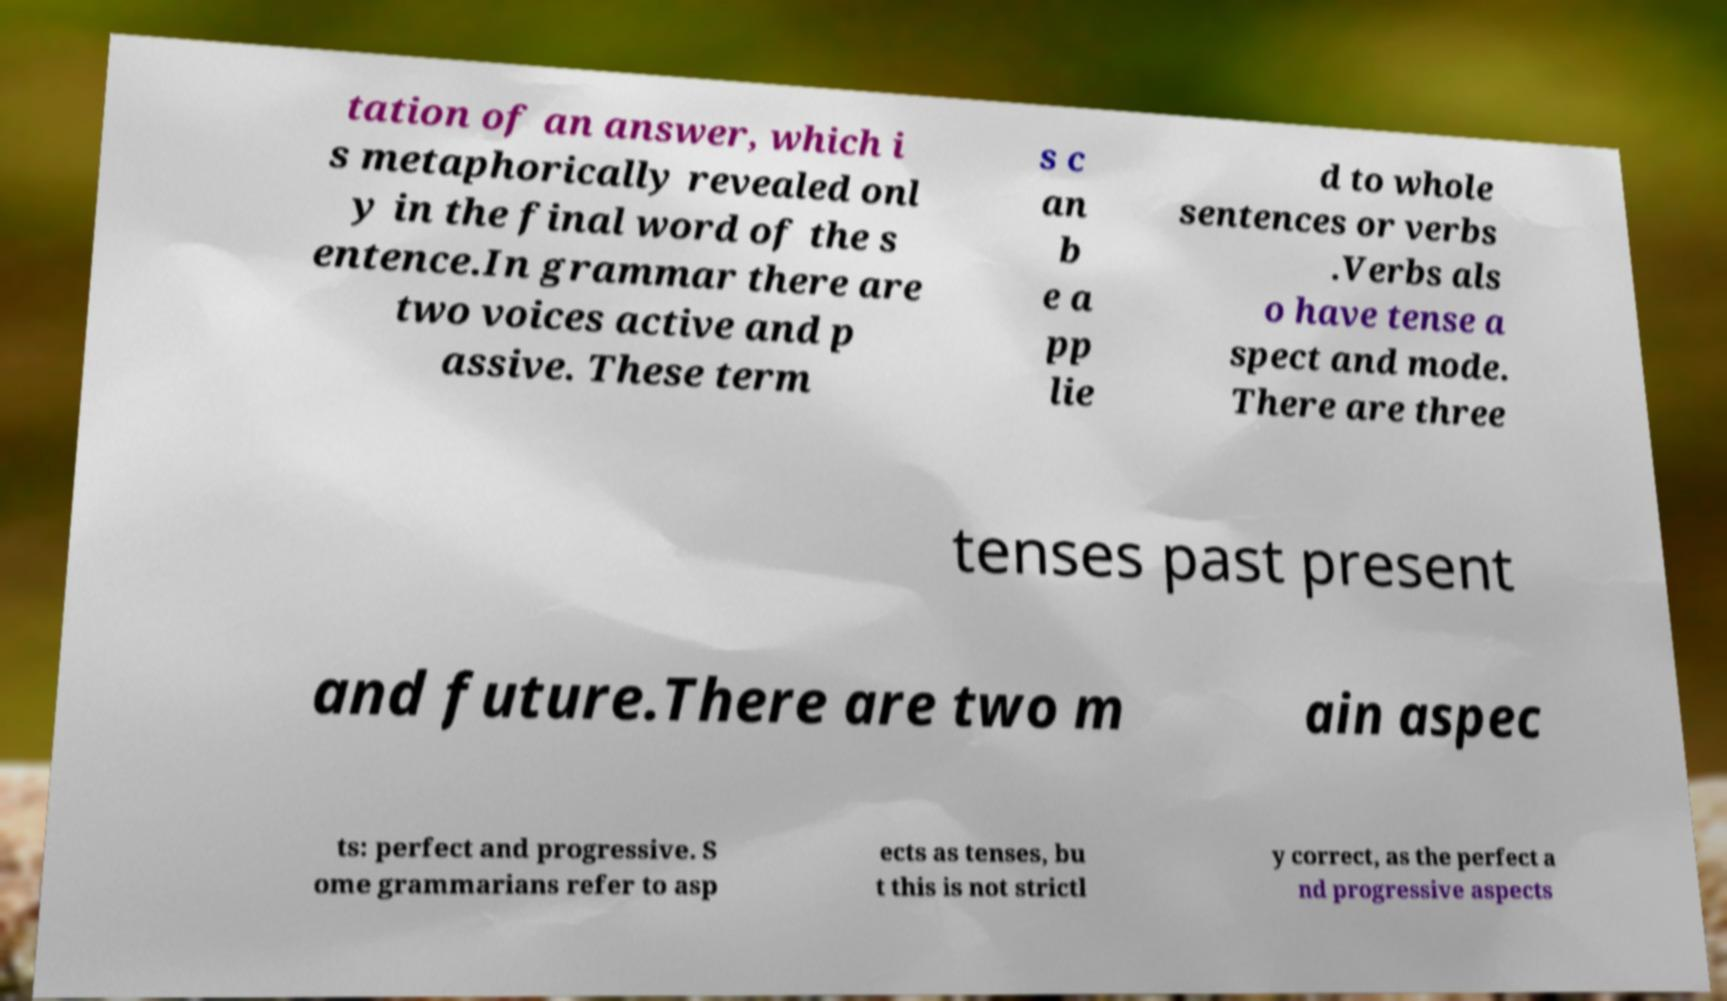Please read and relay the text visible in this image. What does it say? tation of an answer, which i s metaphorically revealed onl y in the final word of the s entence.In grammar there are two voices active and p assive. These term s c an b e a pp lie d to whole sentences or verbs .Verbs als o have tense a spect and mode. There are three tenses past present and future.There are two m ain aspec ts: perfect and progressive. S ome grammarians refer to asp ects as tenses, bu t this is not strictl y correct, as the perfect a nd progressive aspects 